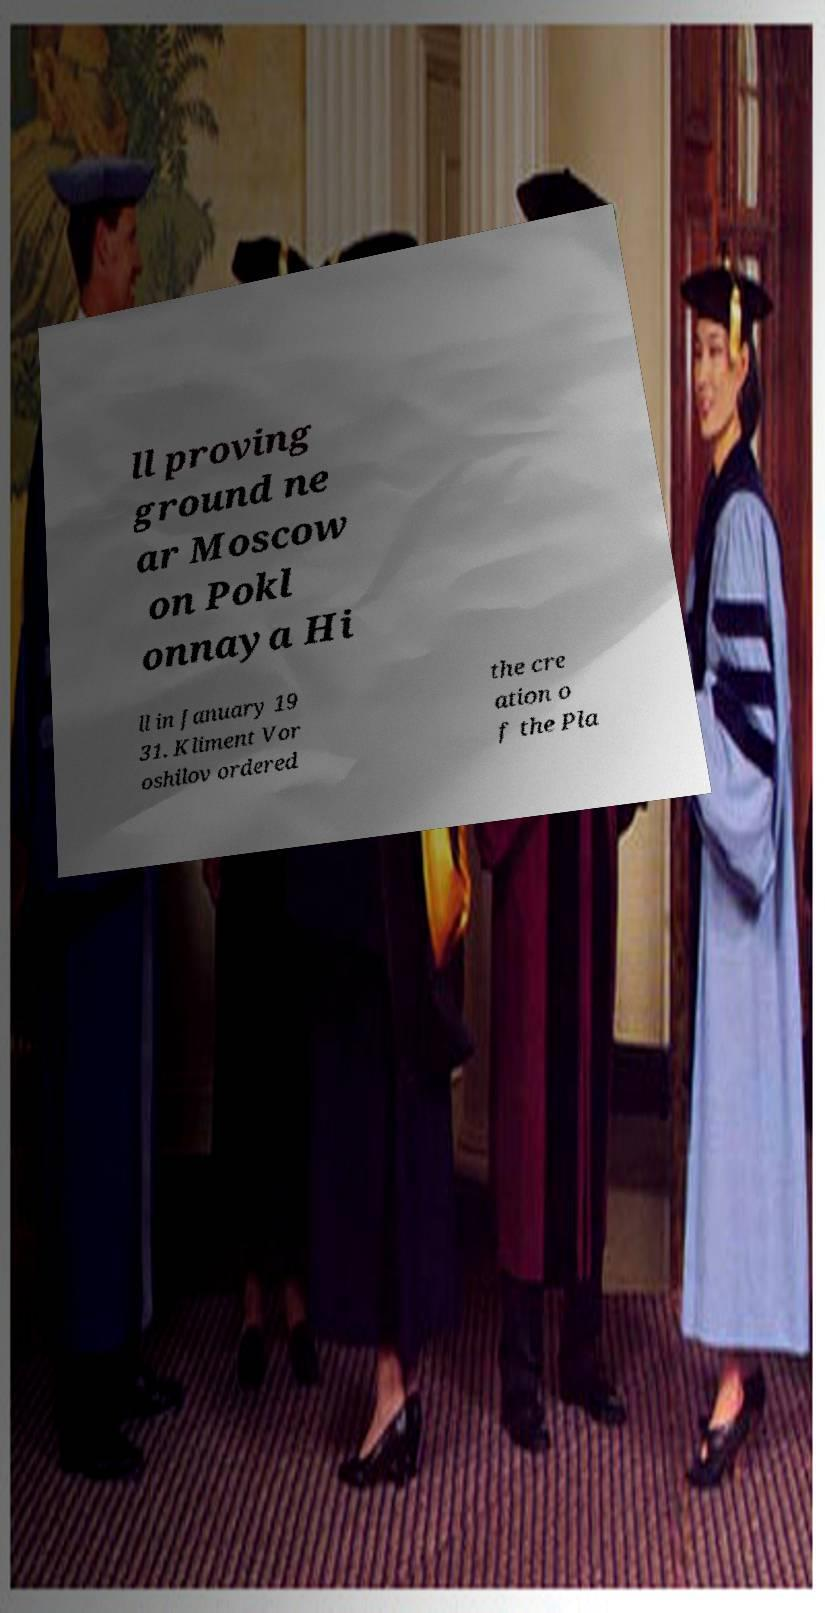There's text embedded in this image that I need extracted. Can you transcribe it verbatim? ll proving ground ne ar Moscow on Pokl onnaya Hi ll in January 19 31. Kliment Vor oshilov ordered the cre ation o f the Pla 